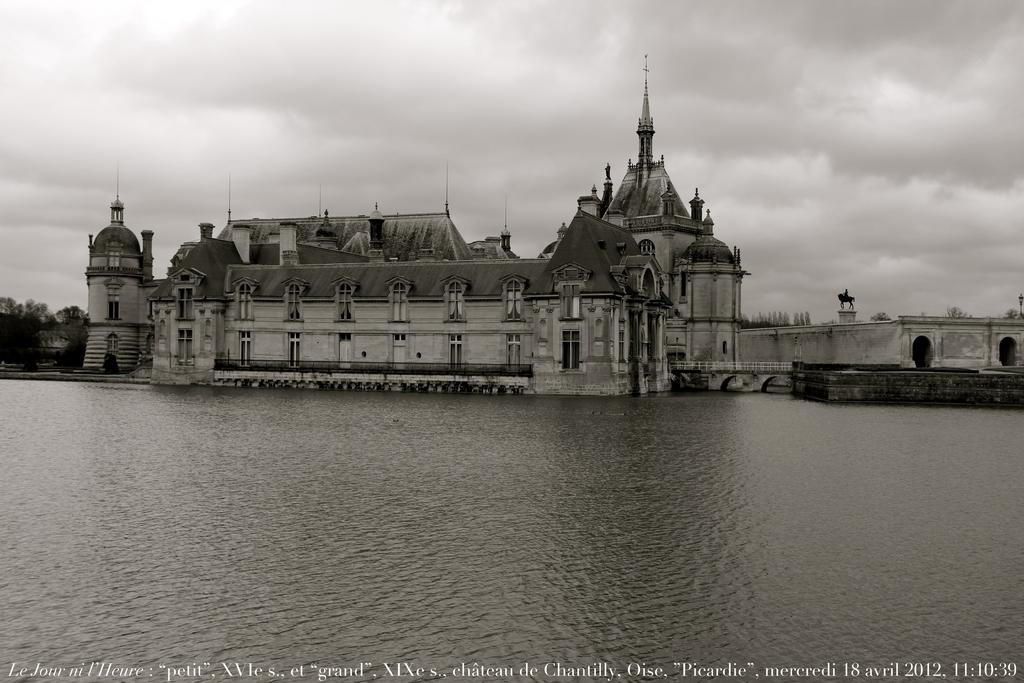What is visible in the image that is not a solid structure? There is water visible in the image. What type of structure can be seen in the image? There is a building in the image. What can be seen in the background of the image? Trees and the sky are visible in the background of the image. Is there any text present in the image? Yes, there is text at the bottom of the image. What type of authority is depicted in the image? There is no authority figure present in the image. Can you tell me how many bats are flying in the image? There are no bats present in the image. 